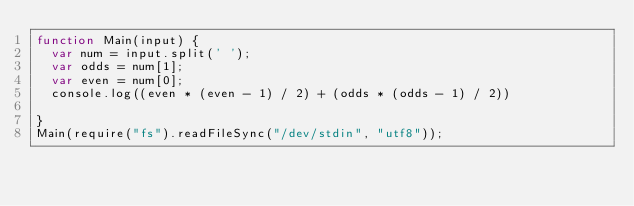Convert code to text. <code><loc_0><loc_0><loc_500><loc_500><_JavaScript_>function Main(input) {
  var num = input.split(' ');
  var odds = num[1];
  var even = num[0];
  console.log((even * (even - 1) / 2) + (odds * (odds - 1) / 2))
  
}
Main(require("fs").readFileSync("/dev/stdin", "utf8"));
</code> 